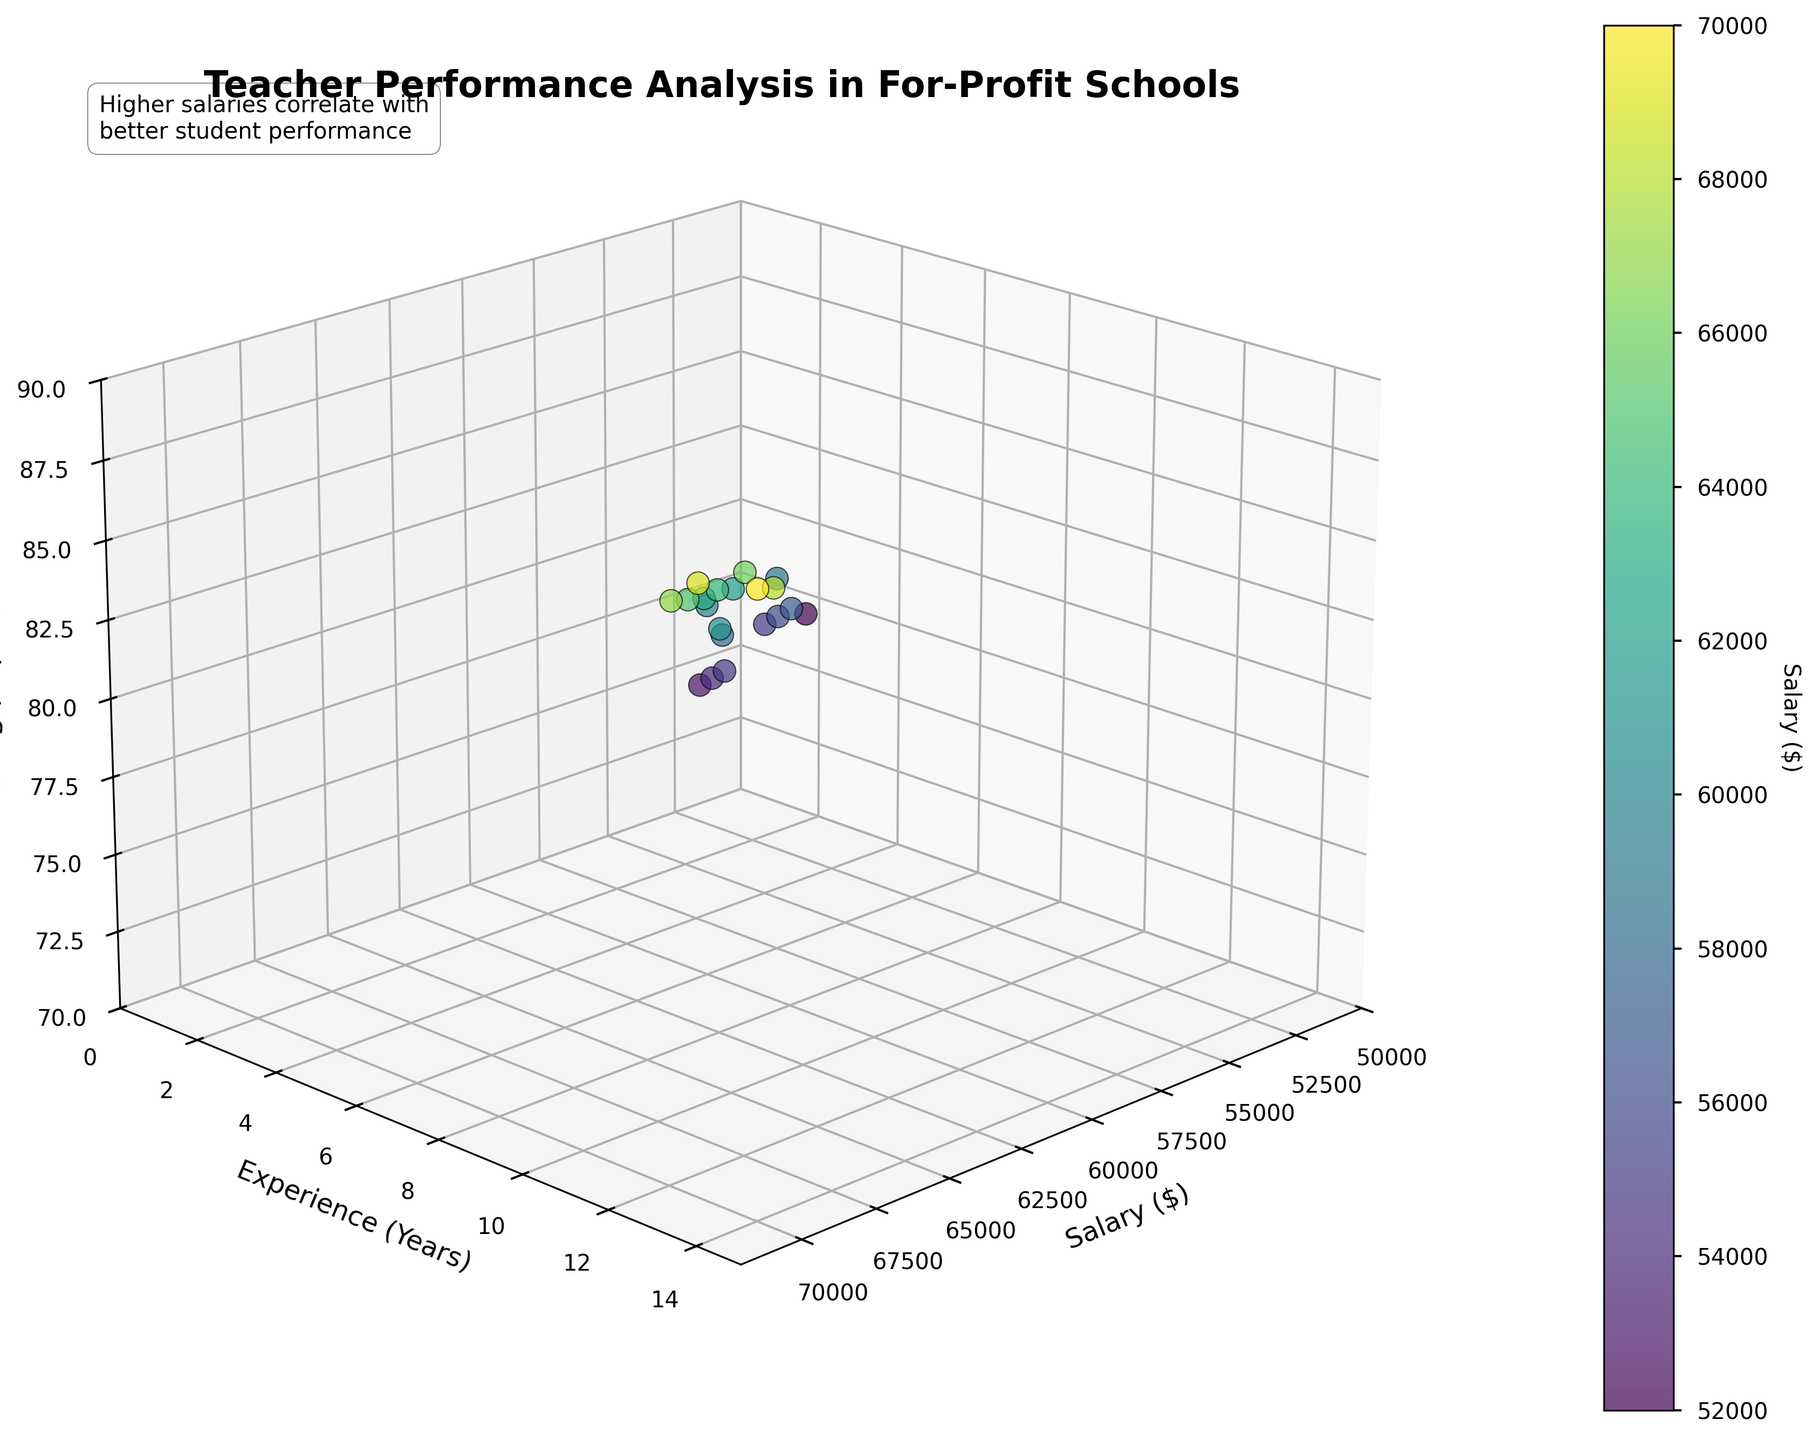How many teachers earn salaries above $65000? Observe the data points with Salary on the x-axis. Count the points where Salary > 65000. There are six teachers with salaries above $65000.
Answer: 6 What is the range of student performance scores in the data? Check the highest and lowest student performance scores on the z-axis. They range from 75 to 89.
Answer: 14 Which teacher has the highest student performance score? The highest z-axis value indicates the highest student performance score. The corresponding data point has a salary of $70000, 14 years of experience, and belongs to Christopher Davis.
Answer: Christopher Davis Are there more teachers with less than 5 years of experience or more? Count the number of teachers with Experience < 5 and those with Experience >= 5 by observing the y-axis. There are 7 teachers with less than 5 years of experience and 13 with 5 or more years.
Answer: More Is there a correlation between salary and student performance scores? Observe the scatter points' trend along the x-axis (salary) and z-axis (student scores). Generally, higher salaries seem to correlate with better student performance scores.
Answer: Yes What is the average salary of teachers who have more than 10 years of experience? Check the salaries on the x-axis for teachers with Experience > 10. The teachers are Robert Taylor ($69000), Christopher Davis ($70000), William Turner ($66000), and Matthew Evans ($68000). Calculate the average: ($69000 + $70000 + $66000 + $68000) / 4 = $68250.
Answer: $68250 Are there any teachers with less than 5 years of experience and student performance scores above 80? Check for data points with Experience < 5 and StudentScore > 80 using the y and z axes. There are no such teachers.
Answer: No How does the student performance score vary with teacher's years of experience? Observe z-axis variation along the y-axis (experience). Generally, as experience increases, student scores tend to improve.
Answer: Improves Which teacher with exactly 7 years of experience has the highest student performance score? Observe data points where Experience = 7 on the y-axis and the highest z-axis value. Michael Chen (82) and Michelle Robinson (83). Michelle Robinson has the highest score.
Answer: Michelle Robinson If a teacher earns $60000, what student performance score can be expected? Observe data points where Salary ≈ 60000 on the x-axis and note corresponding z-axis values. Expectations: Between 82-83.
Answer: 82-83 